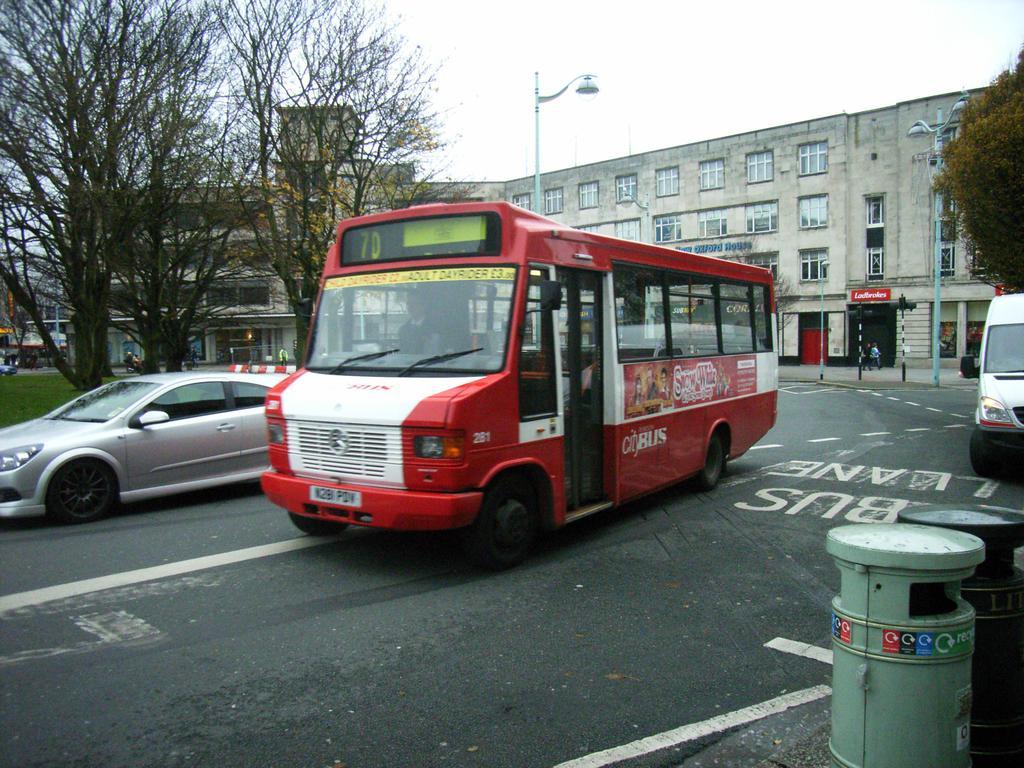Can you describe this image briefly? In this image I can see few vehicles. In front the vehicle is in white and red color, background I can see few light poles, buildings in cream color, trees in green color and the sky is in white color. 